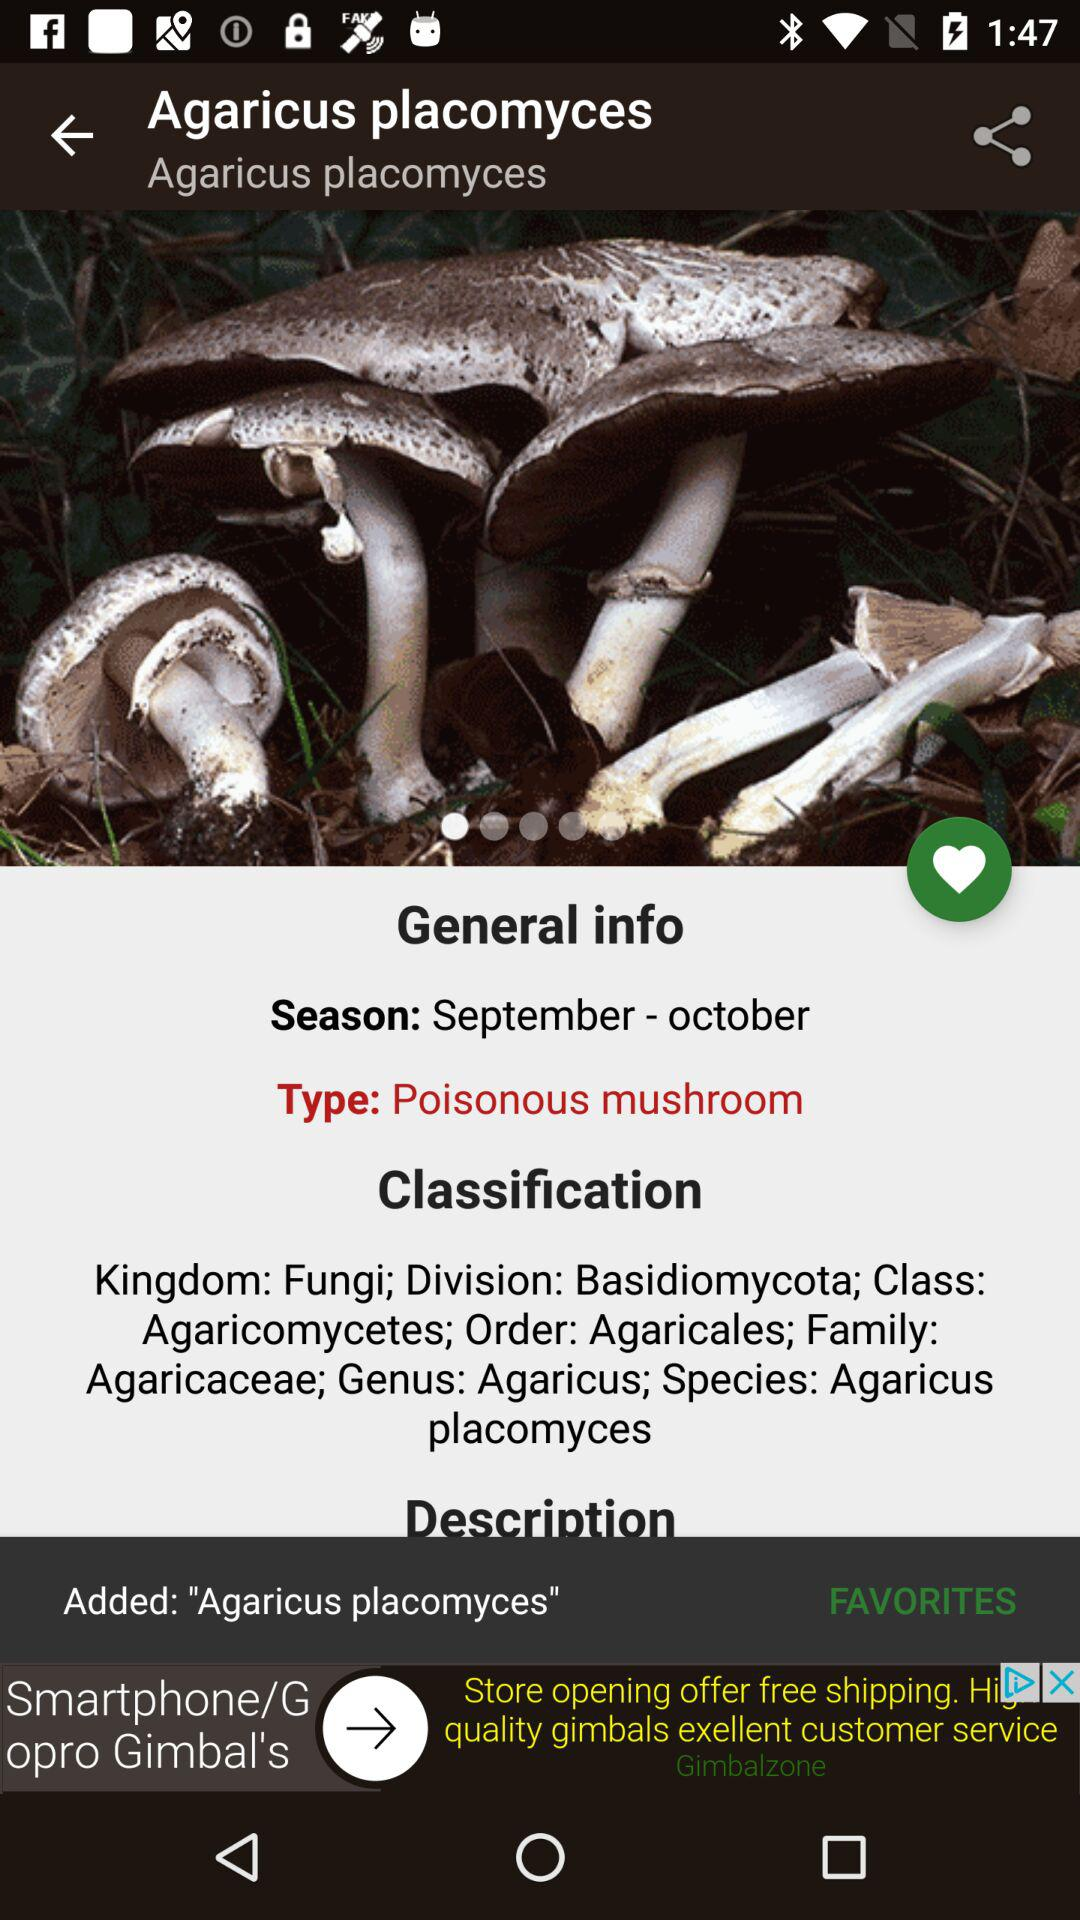What is the classification? The classification is "Kingdom: Fungi; Division: Basidiomycota; Class: Agaricomycetes; Order: Agaricales; Family: Agaricaceae; Genus: Agaricus; Species: Agaricus placomyces". 